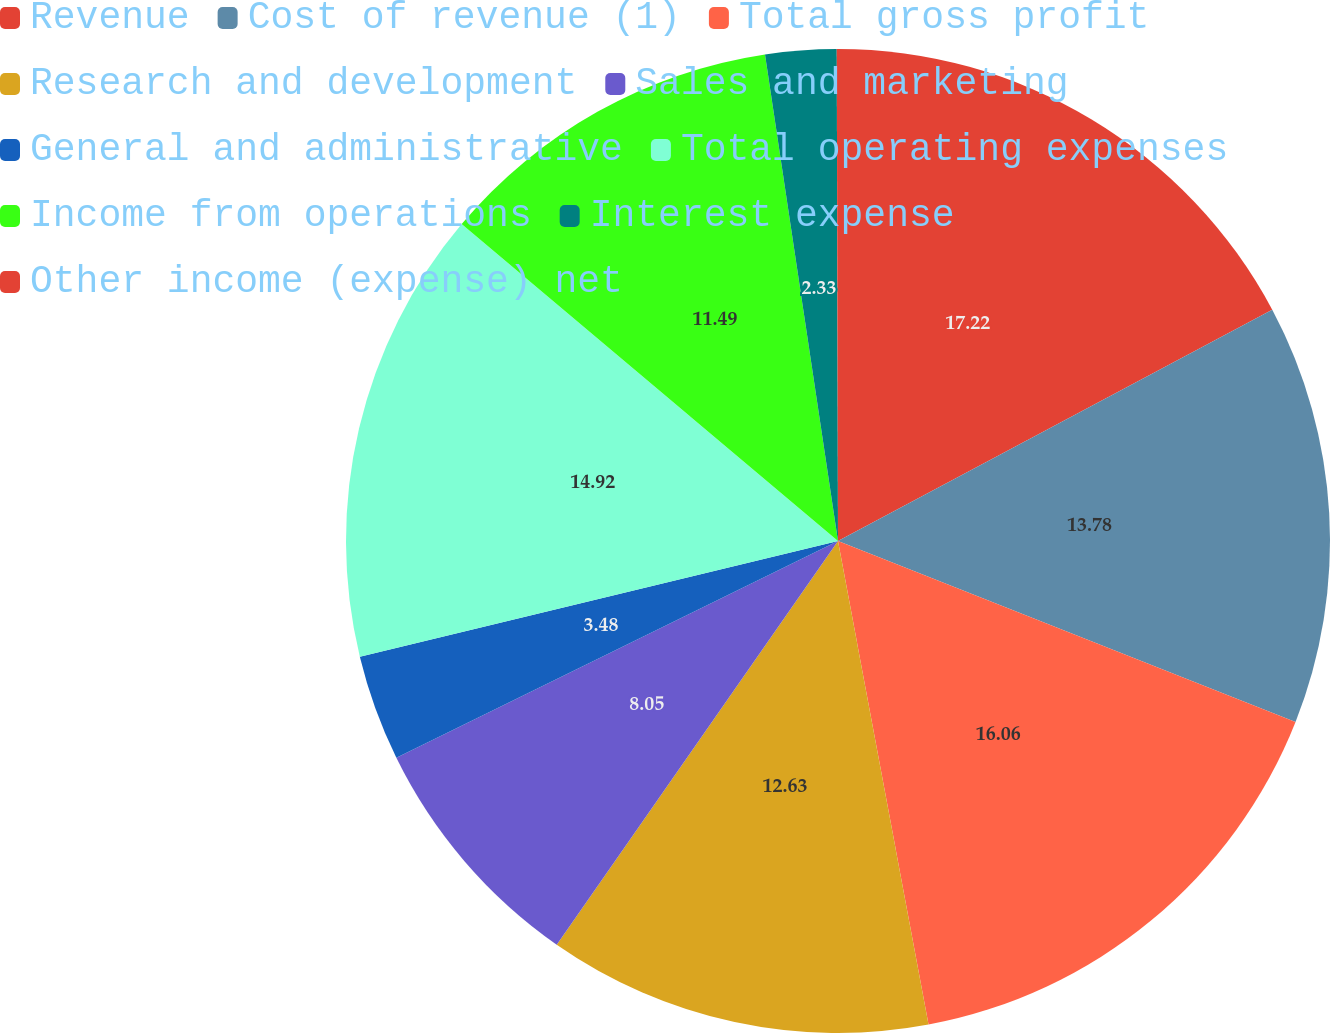Convert chart to OTSL. <chart><loc_0><loc_0><loc_500><loc_500><pie_chart><fcel>Revenue<fcel>Cost of revenue (1)<fcel>Total gross profit<fcel>Research and development<fcel>Sales and marketing<fcel>General and administrative<fcel>Total operating expenses<fcel>Income from operations<fcel>Interest expense<fcel>Other income (expense) net<nl><fcel>17.21%<fcel>13.78%<fcel>16.06%<fcel>12.63%<fcel>8.05%<fcel>3.48%<fcel>14.92%<fcel>11.49%<fcel>2.33%<fcel>0.04%<nl></chart> 